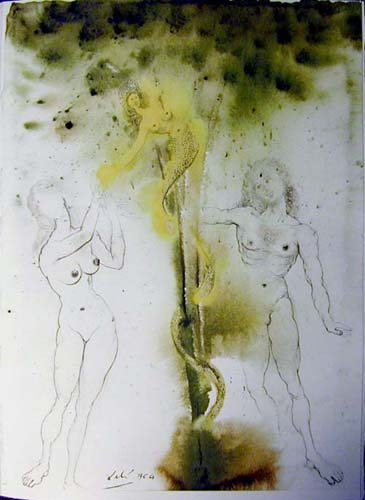What does the serpentine object held by the figure symbolize? The serpentine object can be interpreted as a symbol of transformation and renewal, much like the snake shedding its skin. It also appears to connect the figures, suggesting themes of interdependence and unity among the forms, which could be seen as different aspects of the same entity or psyche. 